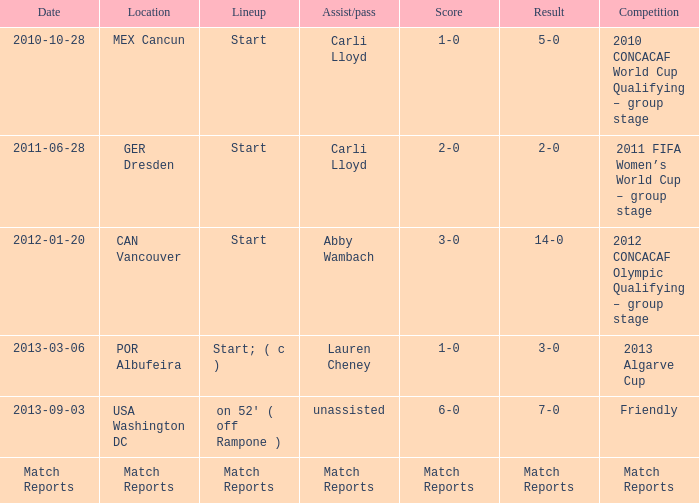Which Assist/pass has a Score of 1-0,a Competition of 2010 concacaf world cup qualifying – group stage? Carli Lloyd. Can you parse all the data within this table? {'header': ['Date', 'Location', 'Lineup', 'Assist/pass', 'Score', 'Result', 'Competition'], 'rows': [['2010-10-28', 'MEX Cancun', 'Start', 'Carli Lloyd', '1-0', '5-0', '2010 CONCACAF World Cup Qualifying – group stage'], ['2011-06-28', 'GER Dresden', 'Start', 'Carli Lloyd', '2-0', '2-0', '2011 FIFA Women’s World Cup – group stage'], ['2012-01-20', 'CAN Vancouver', 'Start', 'Abby Wambach', '3-0', '14-0', '2012 CONCACAF Olympic Qualifying – group stage'], ['2013-03-06', 'POR Albufeira', 'Start; ( c )', 'Lauren Cheney', '1-0', '3-0', '2013 Algarve Cup'], ['2013-09-03', 'USA Washington DC', "on 52' ( off Rampone )", 'unassisted', '6-0', '7-0', 'Friendly'], ['Match Reports', 'Match Reports', 'Match Reports', 'Match Reports', 'Match Reports', 'Match Reports', 'Match Reports']]} 